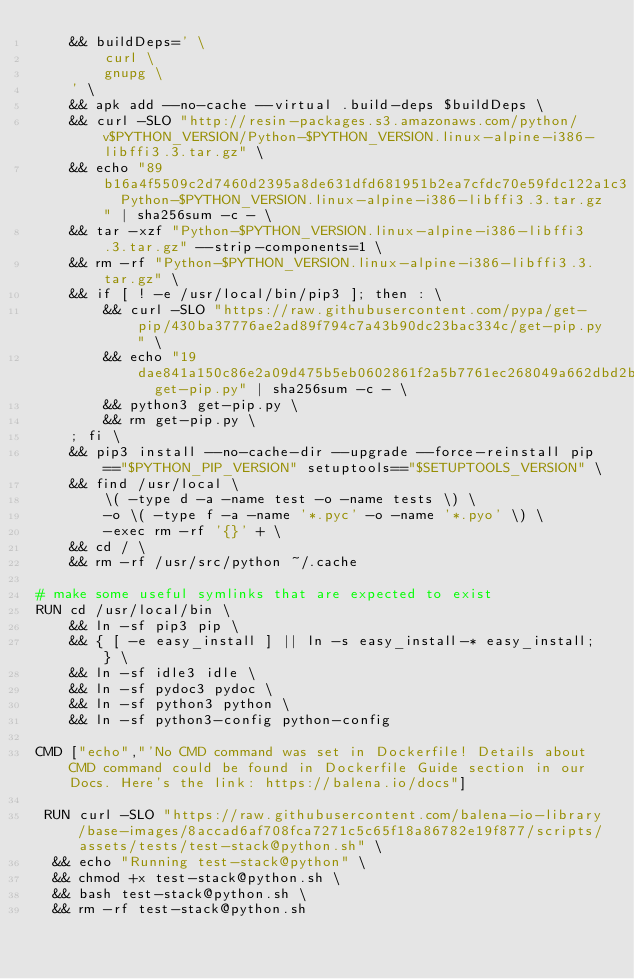<code> <loc_0><loc_0><loc_500><loc_500><_Dockerfile_>	&& buildDeps=' \
		curl \
		gnupg \
	' \
	&& apk add --no-cache --virtual .build-deps $buildDeps \
	&& curl -SLO "http://resin-packages.s3.amazonaws.com/python/v$PYTHON_VERSION/Python-$PYTHON_VERSION.linux-alpine-i386-libffi3.3.tar.gz" \
	&& echo "89b16a4f5509c2d7460d2395a8de631dfd681951b2ea7cfdc70e59fdc122a1c3  Python-$PYTHON_VERSION.linux-alpine-i386-libffi3.3.tar.gz" | sha256sum -c - \
	&& tar -xzf "Python-$PYTHON_VERSION.linux-alpine-i386-libffi3.3.tar.gz" --strip-components=1 \
	&& rm -rf "Python-$PYTHON_VERSION.linux-alpine-i386-libffi3.3.tar.gz" \
	&& if [ ! -e /usr/local/bin/pip3 ]; then : \
		&& curl -SLO "https://raw.githubusercontent.com/pypa/get-pip/430ba37776ae2ad89f794c7a43b90dc23bac334c/get-pip.py" \
		&& echo "19dae841a150c86e2a09d475b5eb0602861f2a5b7761ec268049a662dbd2bd0c  get-pip.py" | sha256sum -c - \
		&& python3 get-pip.py \
		&& rm get-pip.py \
	; fi \
	&& pip3 install --no-cache-dir --upgrade --force-reinstall pip=="$PYTHON_PIP_VERSION" setuptools=="$SETUPTOOLS_VERSION" \
	&& find /usr/local \
		\( -type d -a -name test -o -name tests \) \
		-o \( -type f -a -name '*.pyc' -o -name '*.pyo' \) \
		-exec rm -rf '{}' + \
	&& cd / \
	&& rm -rf /usr/src/python ~/.cache

# make some useful symlinks that are expected to exist
RUN cd /usr/local/bin \
	&& ln -sf pip3 pip \
	&& { [ -e easy_install ] || ln -s easy_install-* easy_install; } \
	&& ln -sf idle3 idle \
	&& ln -sf pydoc3 pydoc \
	&& ln -sf python3 python \
	&& ln -sf python3-config python-config

CMD ["echo","'No CMD command was set in Dockerfile! Details about CMD command could be found in Dockerfile Guide section in our Docs. Here's the link: https://balena.io/docs"]

 RUN curl -SLO "https://raw.githubusercontent.com/balena-io-library/base-images/8accad6af708fca7271c5c65f18a86782e19f877/scripts/assets/tests/test-stack@python.sh" \
  && echo "Running test-stack@python" \
  && chmod +x test-stack@python.sh \
  && bash test-stack@python.sh \
  && rm -rf test-stack@python.sh 
</code> 